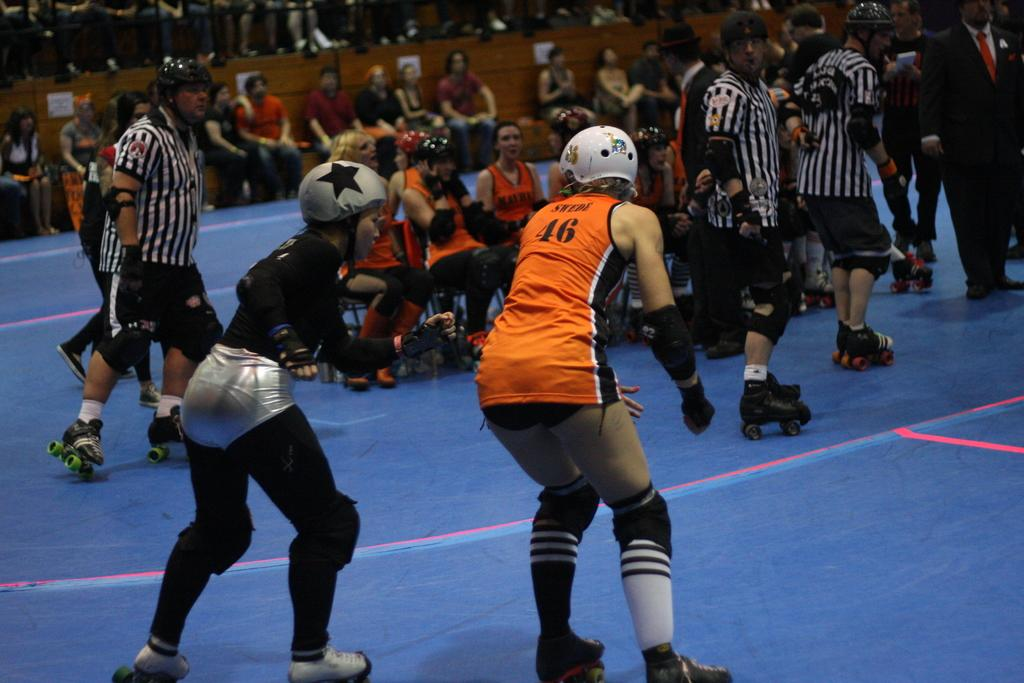What is happening in the image? There are people in the image, some of whom are sitting and some are skating. Can you describe the positions of the people in the image? Some people are sitting, while others are skating. Are there any people sitting in the background of the image? Yes, there are people sitting in the background of the image. What type of idea is being cooked in the hospital in the image? There is no mention of a hospital or cooking in the image; it features people sitting and skating. 